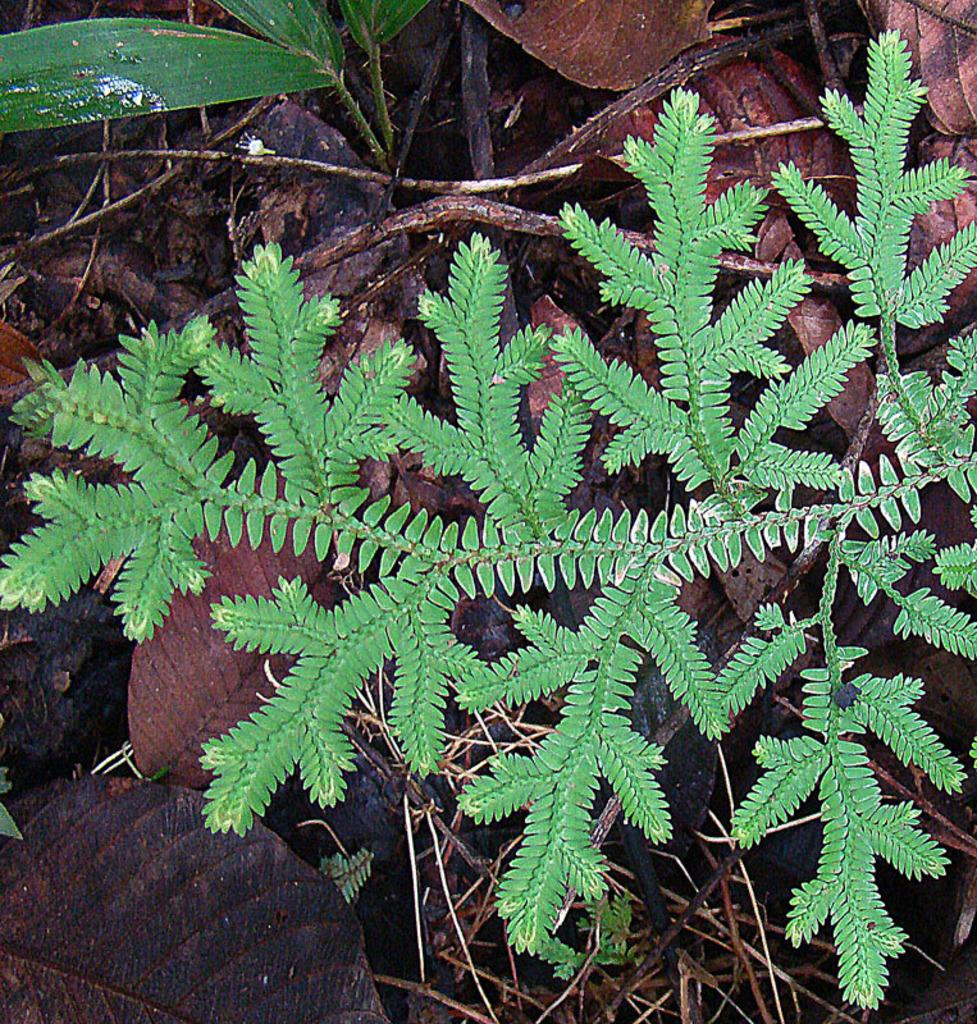What type of living organisms can be seen in the image? Plants can be seen in the image. What is the condition of the leaves on the plants? Dried leaves are present in the image. What else can be seen on the plants? Twigs are visible in the image. On what surface are the plants and other objects located? The objects are on a surface. What type of trousers can be seen in the image? There are no trousers present in the image; it features plants, dried leaves, and twigs. 